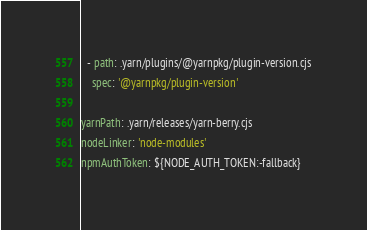<code> <loc_0><loc_0><loc_500><loc_500><_YAML_>  - path: .yarn/plugins/@yarnpkg/plugin-version.cjs
    spec: '@yarnpkg/plugin-version'

yarnPath: .yarn/releases/yarn-berry.cjs
nodeLinker: 'node-modules'
npmAuthToken: ${NODE_AUTH_TOKEN:-fallback}
</code> 